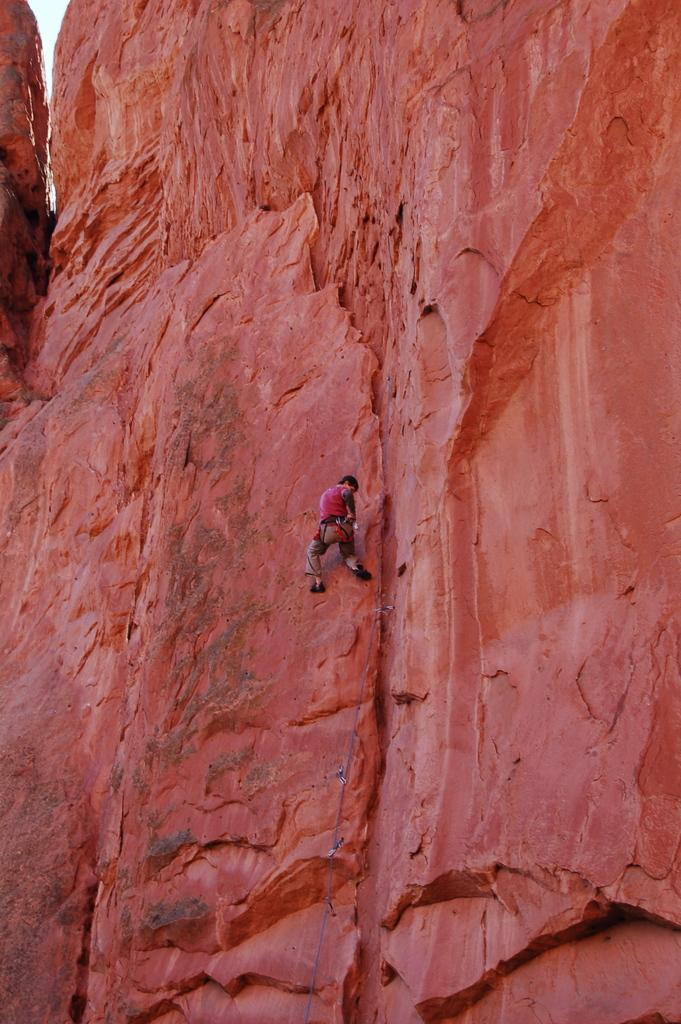What type of landscape is depicted in the image? There are red rock hills in the image. Can you describe any living beings in the image? There is a person in the image. What type of animal can be seen grazing in the red rock hills in the image? There are no animals visible in the image; it only features red rock hills and a person. Can you tell me how much oil is being extracted from the red rock hills in the image? There is no indication of oil extraction in the image; it only features red rock hills and a person. 